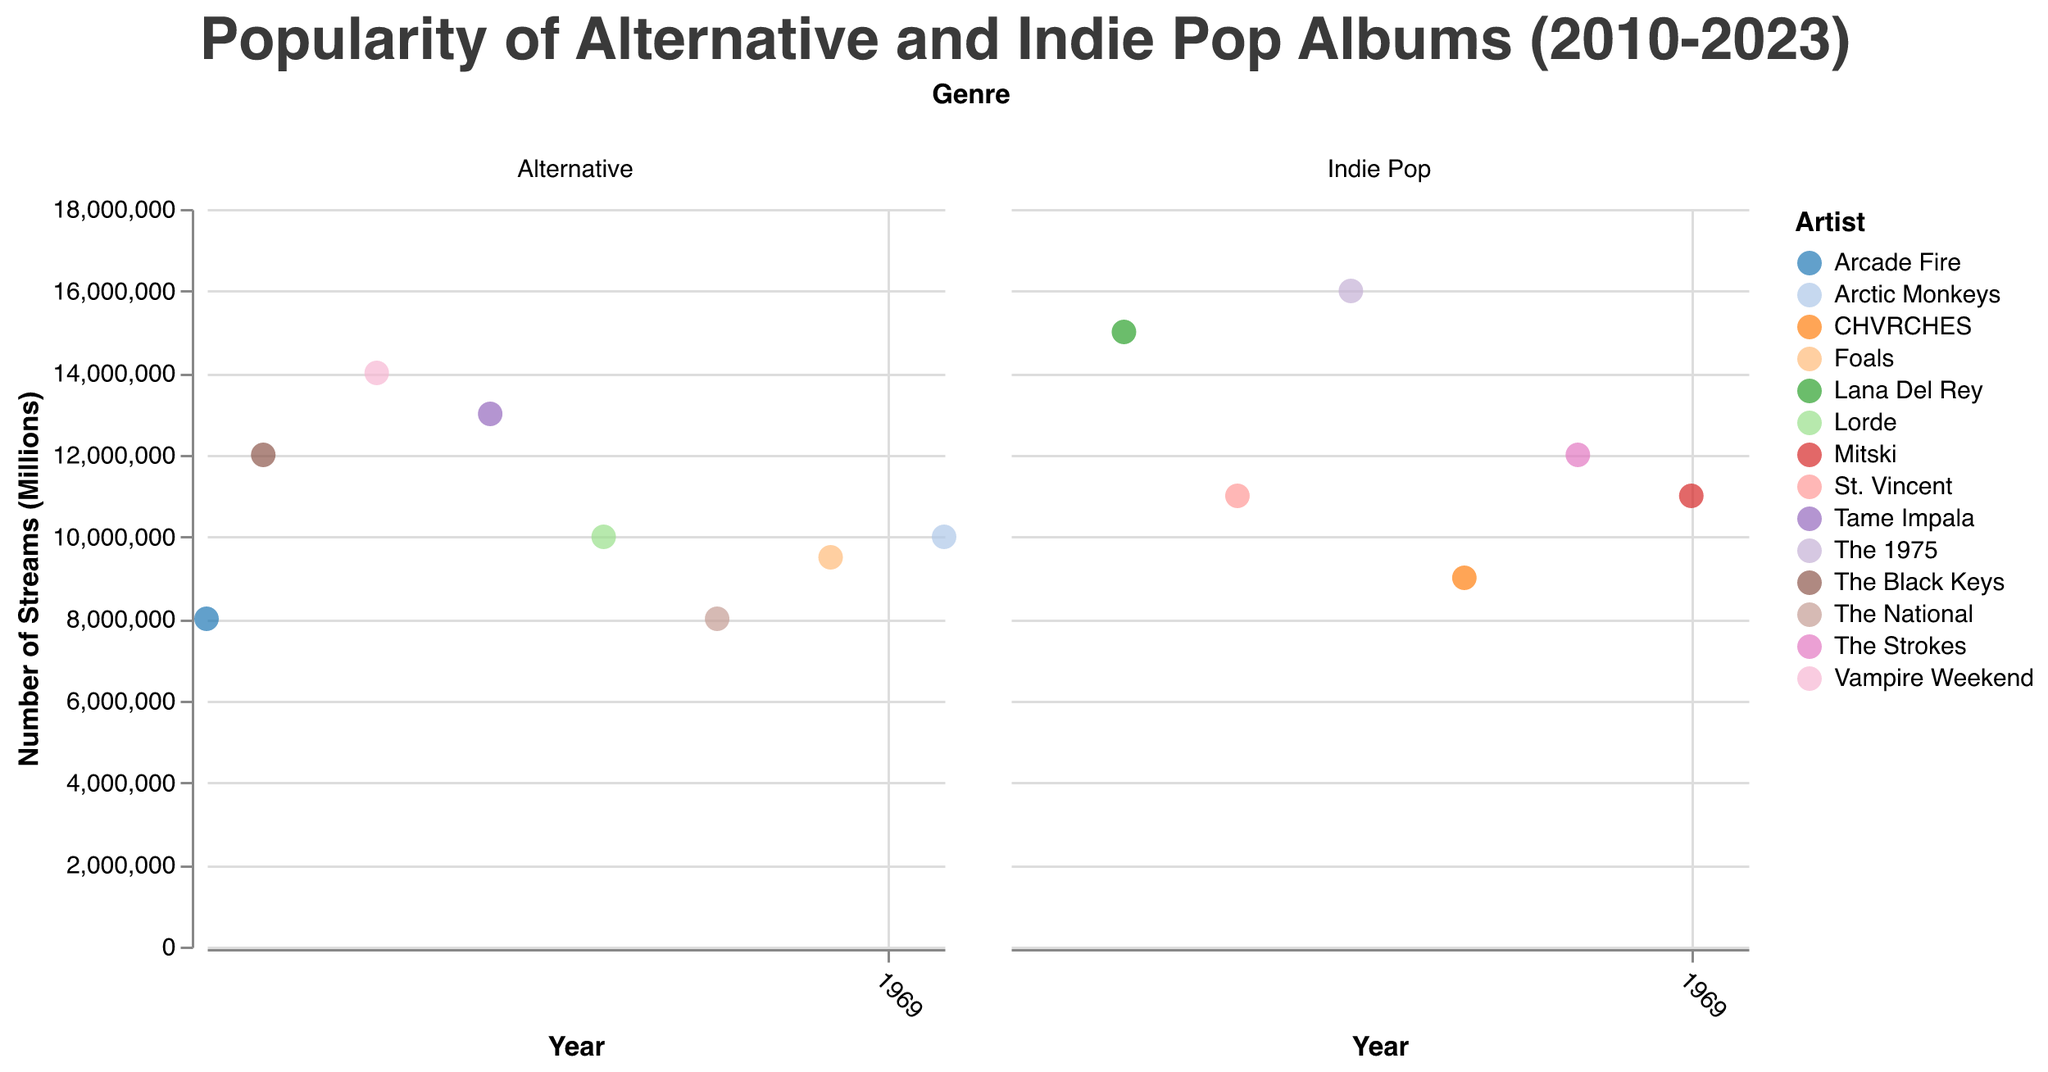What is the title of the plot? The title of the plot is usually placed at the top and is prominently displayed. In this case, it is "Popularity of Alternative and Indie Pop Albums (2010-2023)".
Answer: Popularity of Alternative and Indie Pop Albums (2010-2023) Which artist's album had the highest number of streams in the Indie Pop genre? To find this, look for the data point with the highest y-axis value in the 'Indie Pop' subplot. The maximum value for 'number_of_streams' is 16000000 streams by The 1975 for the album "I Like It When You Sleep" in 2016.
Answer: The 1975 In which year did Alternative and Indie Pop genres both have albums with an equal number of streams? Evaluate the data points for both genres for any matching y-axis values (number of streams). In 2010, both Arcade Fire (Alternative) and The National (Alternative) had albums with 8000000 streams, but only Alternative was mentioned, meaning there is no year where both genres had the same streams.
Answer: None How has the popularity of the Alternative genre changed from 2010 to 2023? Identify the trend of data points in the 'Alternative' subplot from 2010 to 2023. Note fluctuations, including the initial value, peaks, and current value. In 2010, streams were 8000000, peaked to 14000000 in 2013, varied over years, and ended at 10000000 in 2023.
Answer: Fluctuated What is the difference in the number of streams between The Black Keys' "El Camino" and Arctic Monkeys' "The Car"? Subtract the streams of the Arctic Monkeys in 2023 (10000000) from The Black Keys in 2011 (12000000).
Answer: 2000000 streams Which album had the least number of streams in the 'Indie Pop' genre? Find the data point with the lowest y-axis value in the Indie Pop subplot. The lowest value is 9000000 streams for CHVRCHES' album "Love Is Dead" in 2018.
Answer: Love Is Dead by CHVRCHES Which year saw the maximum cumulative streams for both genres combined? Sum the streams for both genres for each year and compare these sums. 2016 has the highest cumulative streams with "10000000" (Alternative) + "16000000" (Indie Pop) totaling 26000000 streams.
Answer: 2016 Which artist appears most frequently in the Alternative genre subplot? Count the number of times each artist appears in the Alternative subplot. Each artist listed appears only once, so there is no artist that appears most frequently.
Answer: None How many albums surpassed 12000000 streams in Indie Pop? Count the number of data points in the Indie Pop subplot where the y-axis value exceeds 12000000. Two albums meet this criterion: "Born to Die" (Lana Del Rey) and "I Like It When You Sleep" (The 1975).
Answer: 2 